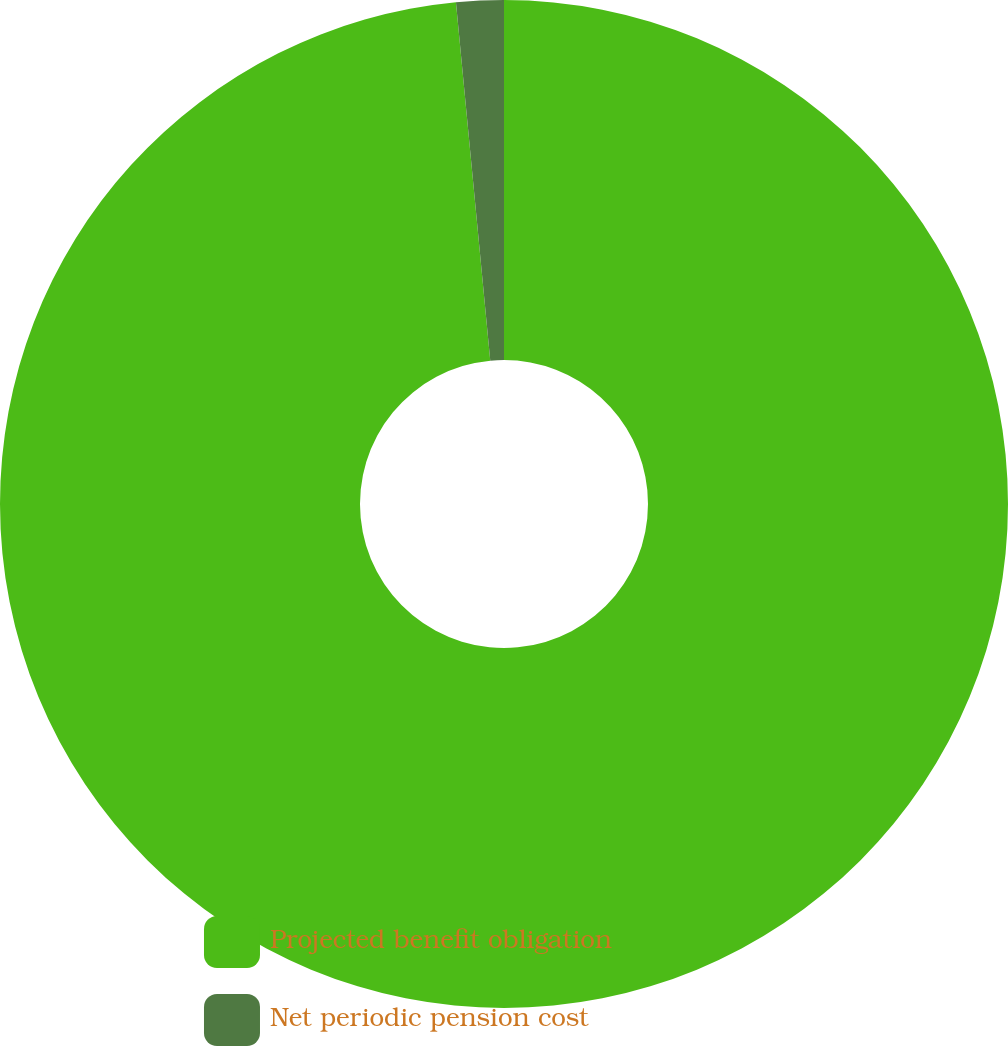<chart> <loc_0><loc_0><loc_500><loc_500><pie_chart><fcel>Projected benefit obligation<fcel>Net periodic pension cost<nl><fcel>98.48%<fcel>1.52%<nl></chart> 